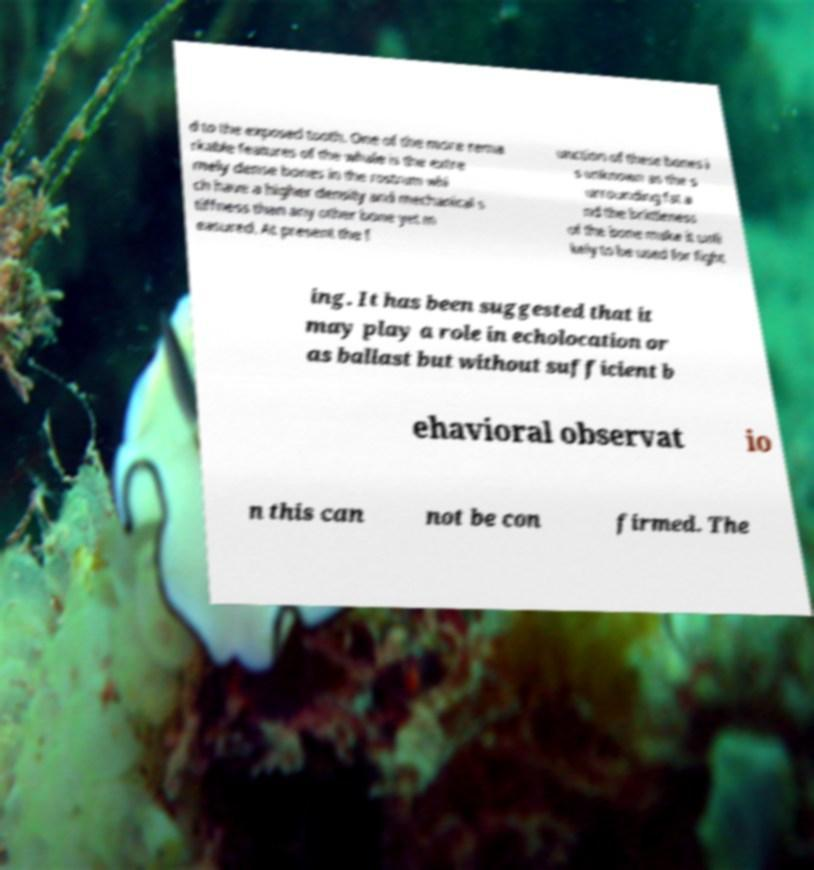Can you read and provide the text displayed in the image?This photo seems to have some interesting text. Can you extract and type it out for me? d to the exposed tooth. One of the more rema rkable features of the whale is the extre mely dense bones in the rostrum whi ch have a higher density and mechanical s tiffness than any other bone yet m easured. At present the f unction of these bones i s unknown as the s urrounding fat a nd the brittleness of the bone make it unli kely to be used for fight ing. It has been suggested that it may play a role in echolocation or as ballast but without sufficient b ehavioral observat io n this can not be con firmed. The 